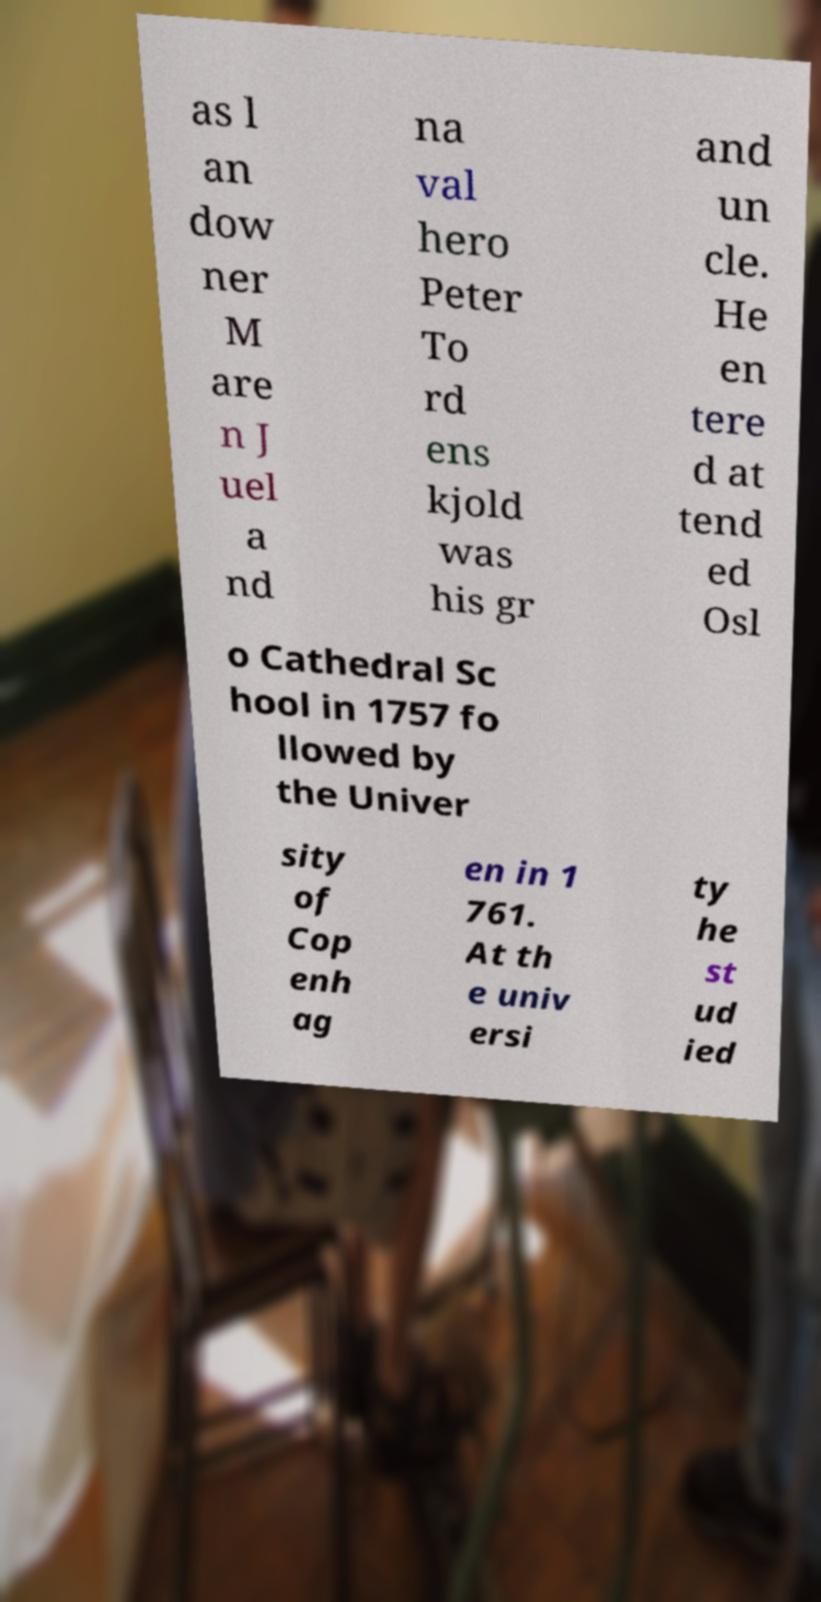Please identify and transcribe the text found in this image. as l an dow ner M are n J uel a nd na val hero Peter To rd ens kjold was his gr and un cle. He en tere d at tend ed Osl o Cathedral Sc hool in 1757 fo llowed by the Univer sity of Cop enh ag en in 1 761. At th e univ ersi ty he st ud ied 